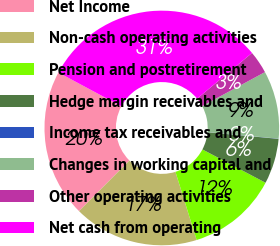Convert chart. <chart><loc_0><loc_0><loc_500><loc_500><pie_chart><fcel>Net Income<fcel>Non-cash operating activities<fcel>Pension and postretirement<fcel>Hedge margin receivables and<fcel>Income tax receivables and<fcel>Changes in working capital and<fcel>Other operating activities<fcel>Net cash from operating<nl><fcel>20.38%<fcel>17.27%<fcel>12.47%<fcel>6.25%<fcel>0.03%<fcel>9.36%<fcel>3.14%<fcel>31.13%<nl></chart> 